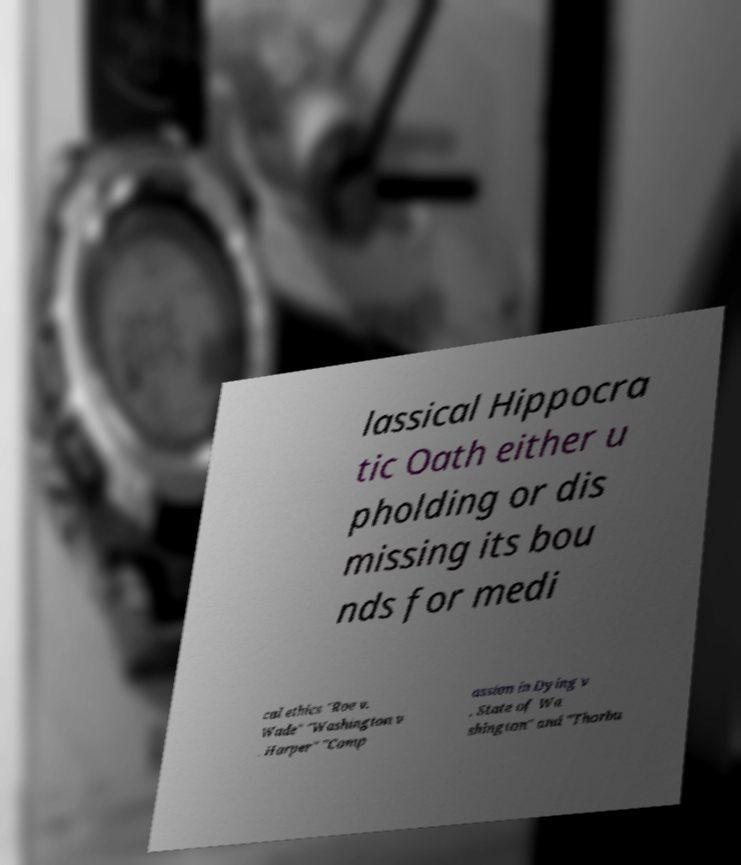Could you extract and type out the text from this image? lassical Hippocra tic Oath either u pholding or dis missing its bou nds for medi cal ethics "Roe v. Wade" "Washington v . Harper" "Comp assion in Dying v . State of Wa shington" and "Thorbu 